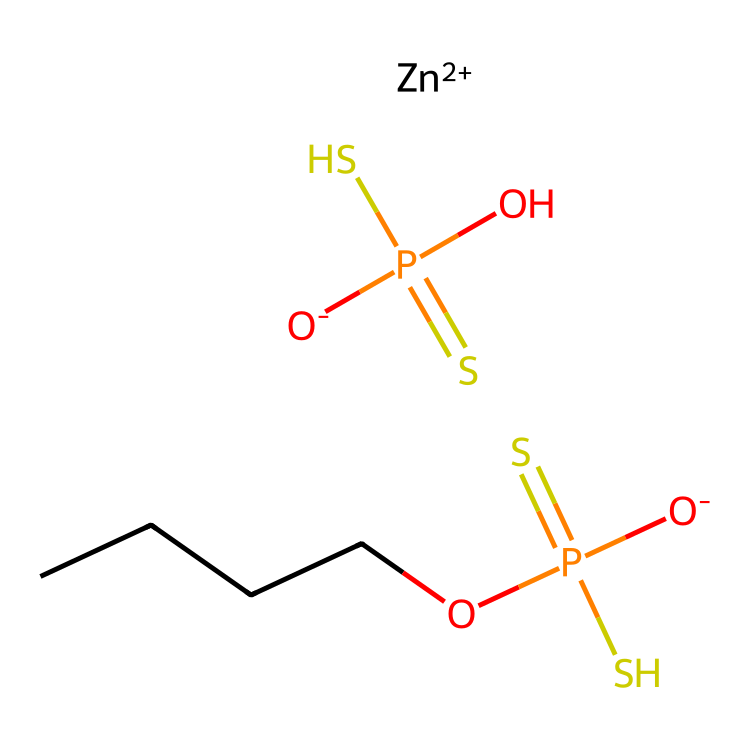What is the molecular formula for zinc dialkyldithiophosphate? The SMILES representation includes elements such as zinc (Zn), oxygen (O), phosphorus (P), sulfur (S), and alkyl (indicated by the "C" in "CCCC"). The formula is derived from counting these elements in the structure.
Answer: Zn(C2H5)2P2S4O2 How many phosphorus atoms are in the structure? The SMILES indicates two phosphorus atoms, as shown by the two occurrences of "P" in the representation.
Answer: 2 What type of bonding is present in ZDDP? The chemical structure shows ionic bonding due to the presence of the zinc ion (Zn2+) and covalent bonding within the dithiophosphate part, indicated by shared electron pairs between phosphorus and sulfur and other atoms.
Answer: Ionic and covalent How many sulfur atoms are in the chemical? By inspecting the SMILES, we see that "S" appears twice in the dithiophosphate moiety and can count the total. There are four sulfur atoms in total, two for each dithiophosphate unit.
Answer: 4 What is the primary function of ZDDP in motor oil? ZDDP primarily acts as an anti-wear additive and antioxidant in motor oils. This prevents the degradation of engine components under high-pressure and high-temperature conditions.
Answer: Anti-wear and antioxidant What is the significance of the alkyl chain represented in the structure? The alkyl chain contributes to the hydrophobic properties of ZDDP, enhancing its solubility in oil while also providing protective characteristics to the engine parts.
Answer: Hydrophobic properties 